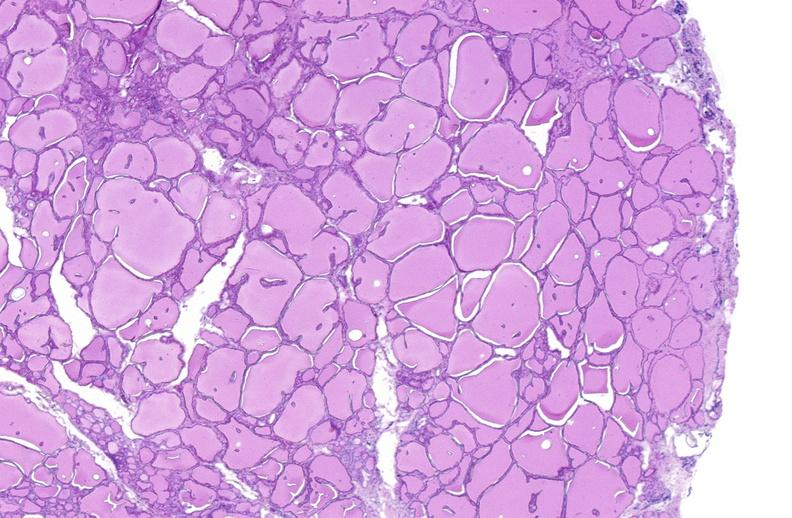does this image show thyroid gland, normal?
Answer the question using a single word or phrase. Yes 